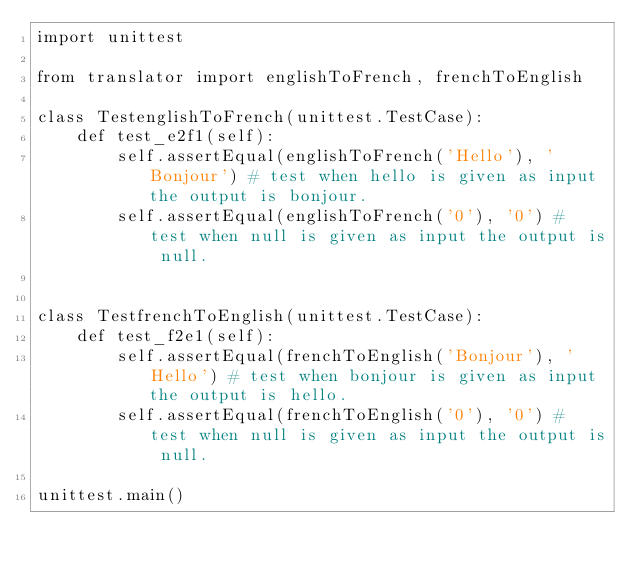<code> <loc_0><loc_0><loc_500><loc_500><_Python_>import unittest

from translator import englishToFrench, frenchToEnglish

class TestenglishToFrench(unittest.TestCase): 
    def test_e2f1(self): 
        self.assertEqual(englishToFrench('Hello'), 'Bonjour') # test when hello is given as input the output is bonjour.
        self.assertEqual(englishToFrench('0'), '0') # test when null is given as input the output is null.
        

class TestfrenchToEnglish(unittest.TestCase): 
    def test_f2e1(self): 
        self.assertEqual(frenchToEnglish('Bonjour'), 'Hello') # test when bonjour is given as input the output is hello.
        self.assertEqual(frenchToEnglish('0'), '0') # test when null is given as input the output is null.
        
unittest.main()</code> 